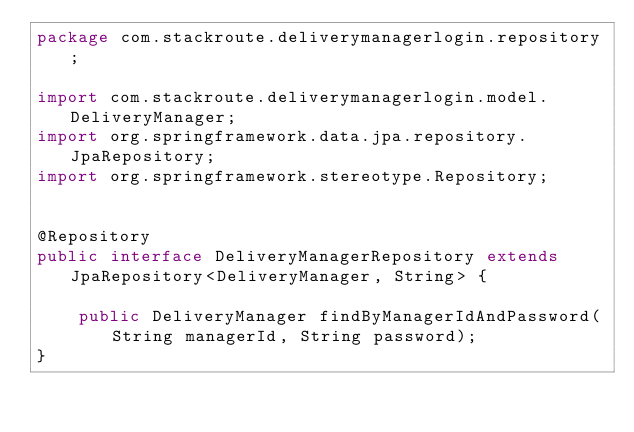<code> <loc_0><loc_0><loc_500><loc_500><_Java_>package com.stackroute.deliverymanagerlogin.repository;

import com.stackroute.deliverymanagerlogin.model.DeliveryManager;
import org.springframework.data.jpa.repository.JpaRepository;
import org.springframework.stereotype.Repository;


@Repository
public interface DeliveryManagerRepository extends JpaRepository<DeliveryManager, String> {

    public DeliveryManager findByManagerIdAndPassword(String managerId, String password);
}
</code> 